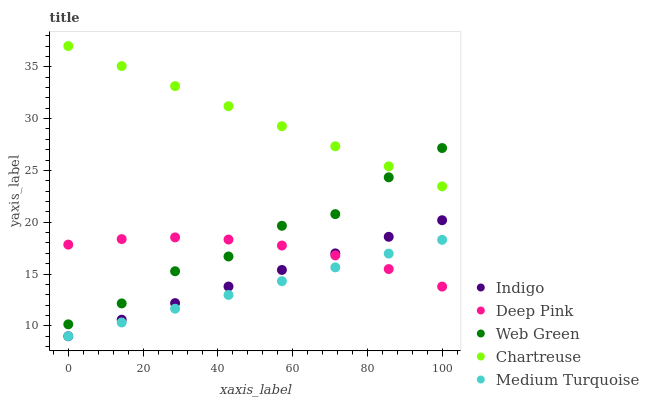Does Medium Turquoise have the minimum area under the curve?
Answer yes or no. Yes. Does Chartreuse have the maximum area under the curve?
Answer yes or no. Yes. Does Deep Pink have the minimum area under the curve?
Answer yes or no. No. Does Deep Pink have the maximum area under the curve?
Answer yes or no. No. Is Medium Turquoise the smoothest?
Answer yes or no. Yes. Is Web Green the roughest?
Answer yes or no. Yes. Is Deep Pink the smoothest?
Answer yes or no. No. Is Deep Pink the roughest?
Answer yes or no. No. Does Indigo have the lowest value?
Answer yes or no. Yes. Does Deep Pink have the lowest value?
Answer yes or no. No. Does Chartreuse have the highest value?
Answer yes or no. Yes. Does Deep Pink have the highest value?
Answer yes or no. No. Is Indigo less than Chartreuse?
Answer yes or no. Yes. Is Chartreuse greater than Deep Pink?
Answer yes or no. Yes. Does Indigo intersect Medium Turquoise?
Answer yes or no. Yes. Is Indigo less than Medium Turquoise?
Answer yes or no. No. Is Indigo greater than Medium Turquoise?
Answer yes or no. No. Does Indigo intersect Chartreuse?
Answer yes or no. No. 